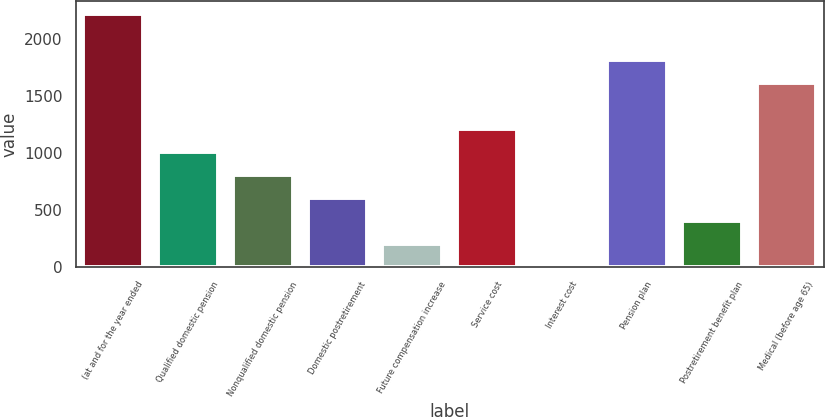Convert chart to OTSL. <chart><loc_0><loc_0><loc_500><loc_500><bar_chart><fcel>(at and for the year ended<fcel>Qualified domestic pension<fcel>Nonqualified domestic pension<fcel>Domestic postretirement<fcel>Future compensation increase<fcel>Service cost<fcel>Interest cost<fcel>Pension plan<fcel>Postretirement benefit plan<fcel>Medical (before age 65)<nl><fcel>2217.28<fcel>1009.84<fcel>808.6<fcel>607.36<fcel>204.88<fcel>1211.08<fcel>3.64<fcel>1814.8<fcel>406.12<fcel>1613.56<nl></chart> 